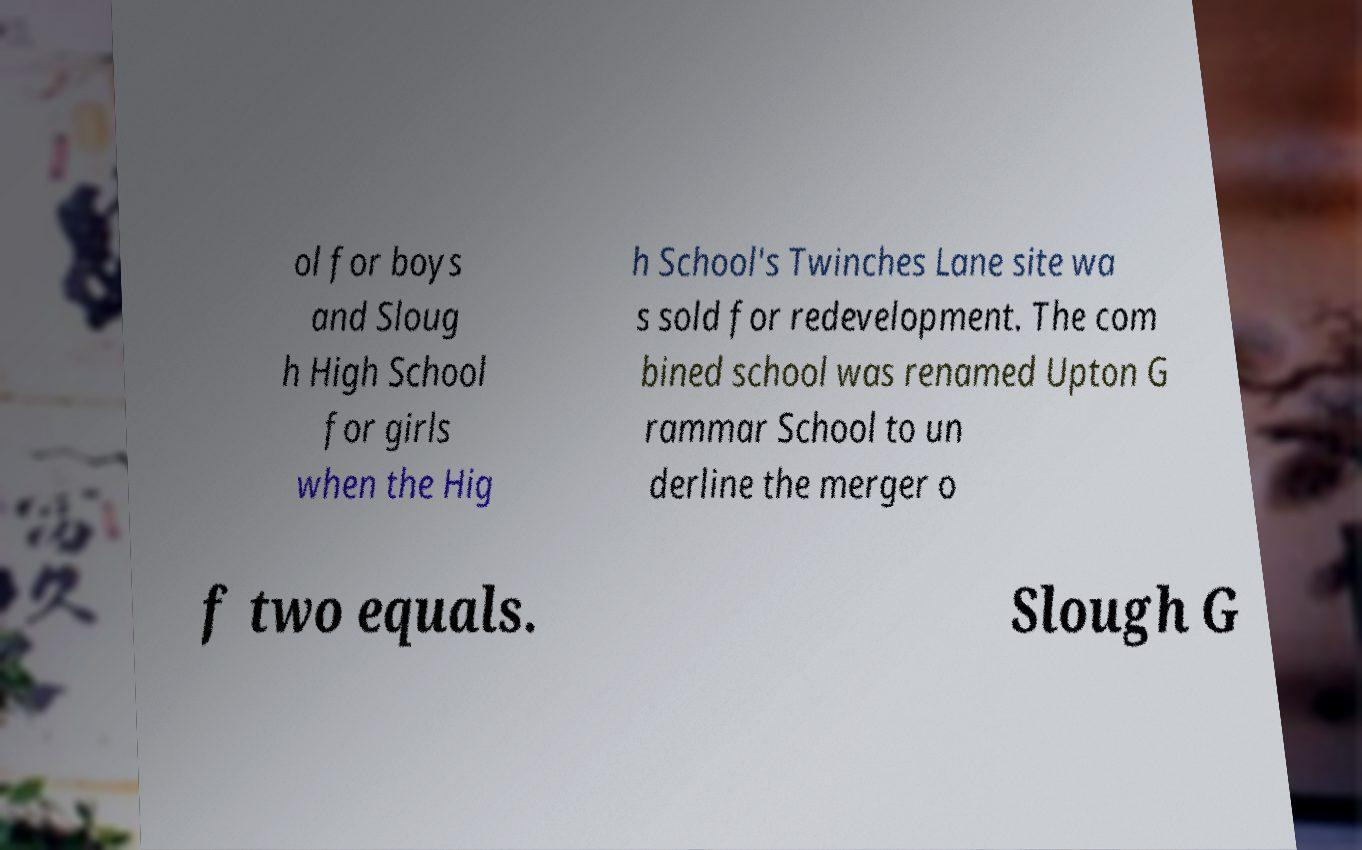Please read and relay the text visible in this image. What does it say? ol for boys and Sloug h High School for girls when the Hig h School's Twinches Lane site wa s sold for redevelopment. The com bined school was renamed Upton G rammar School to un derline the merger o f two equals. Slough G 